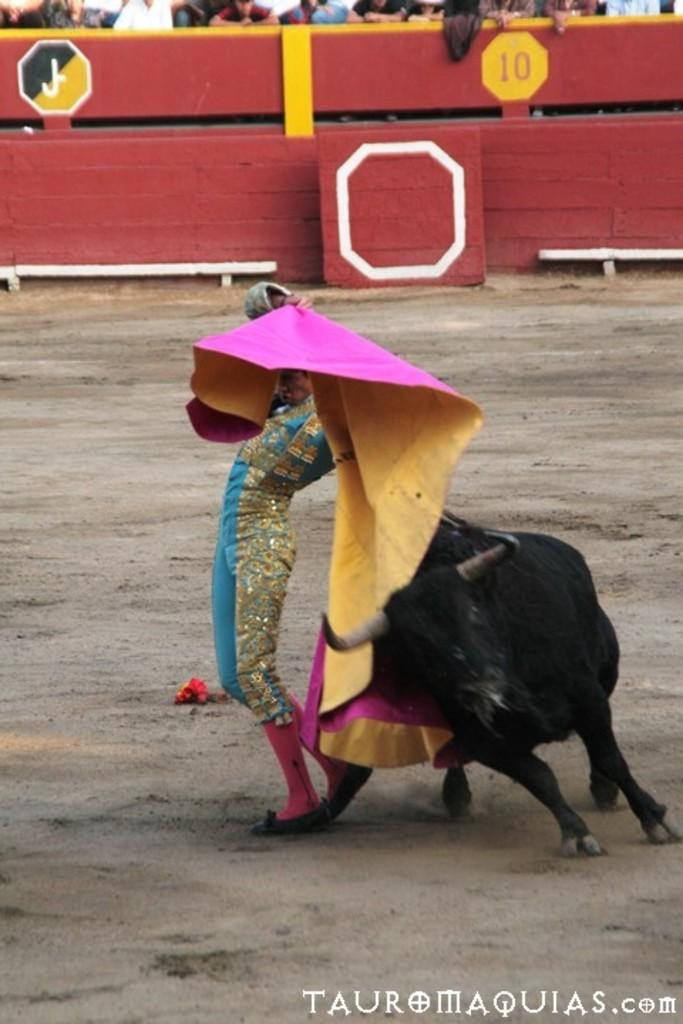What is happening between the bull and the person in the image? There is a bull fighting with a person in the image. What can be seen in the background of the image? There is a fencing in the image. What is on the other side of the fencing? There are people on the other side of the fencing. What type of vein can be seen in the image? There is no vein present in the image. Is there a volcano visible in the image? No, there is no volcano present in the image. 